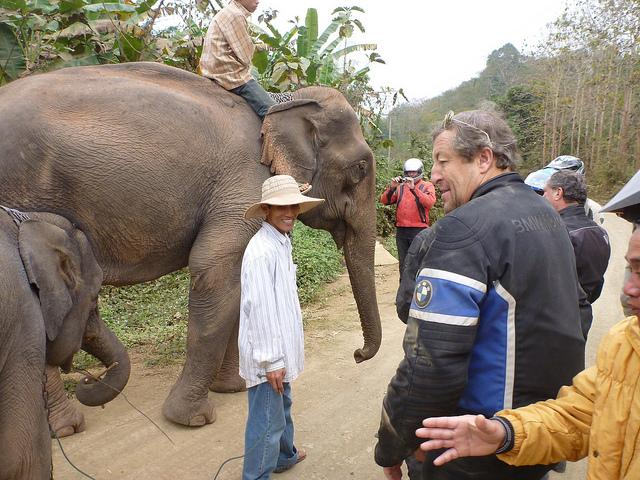Which of these men is most likely from a different country? Please explain your reasoning. bmw jacket. He has a different skin tone than the rest of the people near him. 